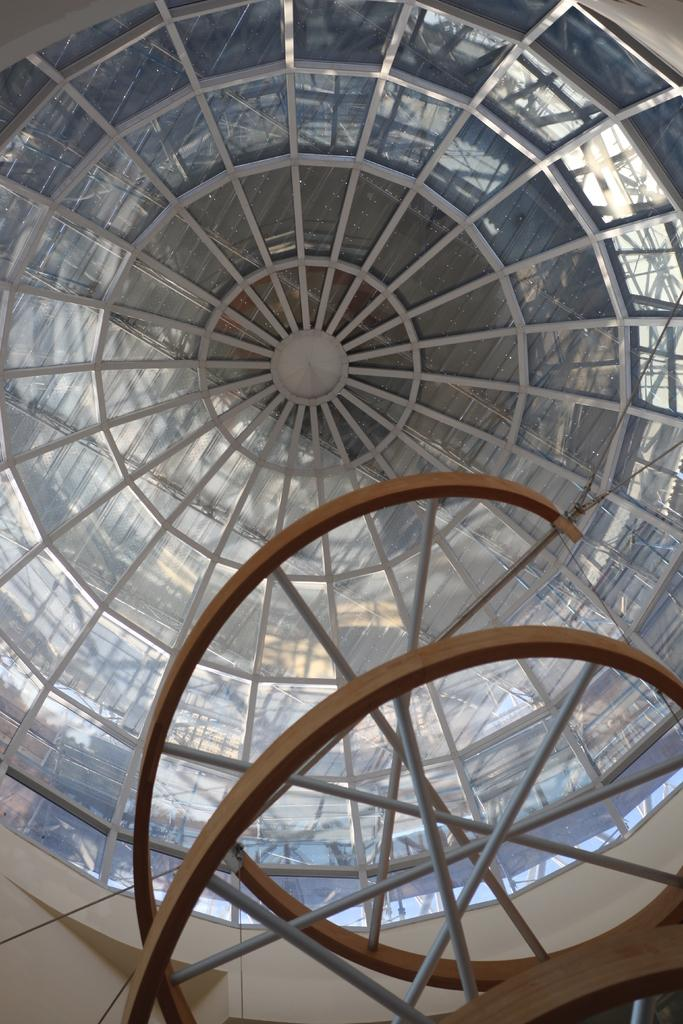What is the main setting of the image? The main setting of the image is the roof top of a building. What objects can be seen on the roof top? There are rods visible in the image. What type of powder is being used to clean the rods in the image? There is no powder or cleaning activity visible in the image; it only shows the roof top and rods. 